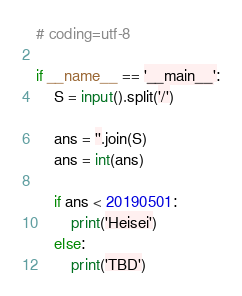Convert code to text. <code><loc_0><loc_0><loc_500><loc_500><_Python_># coding=utf-8

if __name__ == '__main__':
    S = input().split('/')

    ans = ''.join(S)
    ans = int(ans)

    if ans < 20190501:
        print('Heisei')
    else:
        print('TBD')</code> 